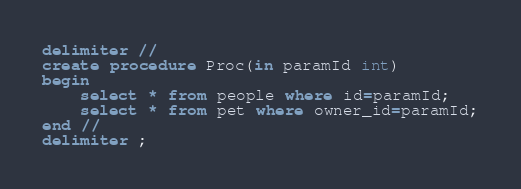Convert code to text. <code><loc_0><loc_0><loc_500><loc_500><_SQL_>
delimiter //
create procedure Proc(in paramId int)
begin
	select * from people where id=paramId;
	select * from pet where owner_id=paramId;
end //
delimiter ;

</code> 